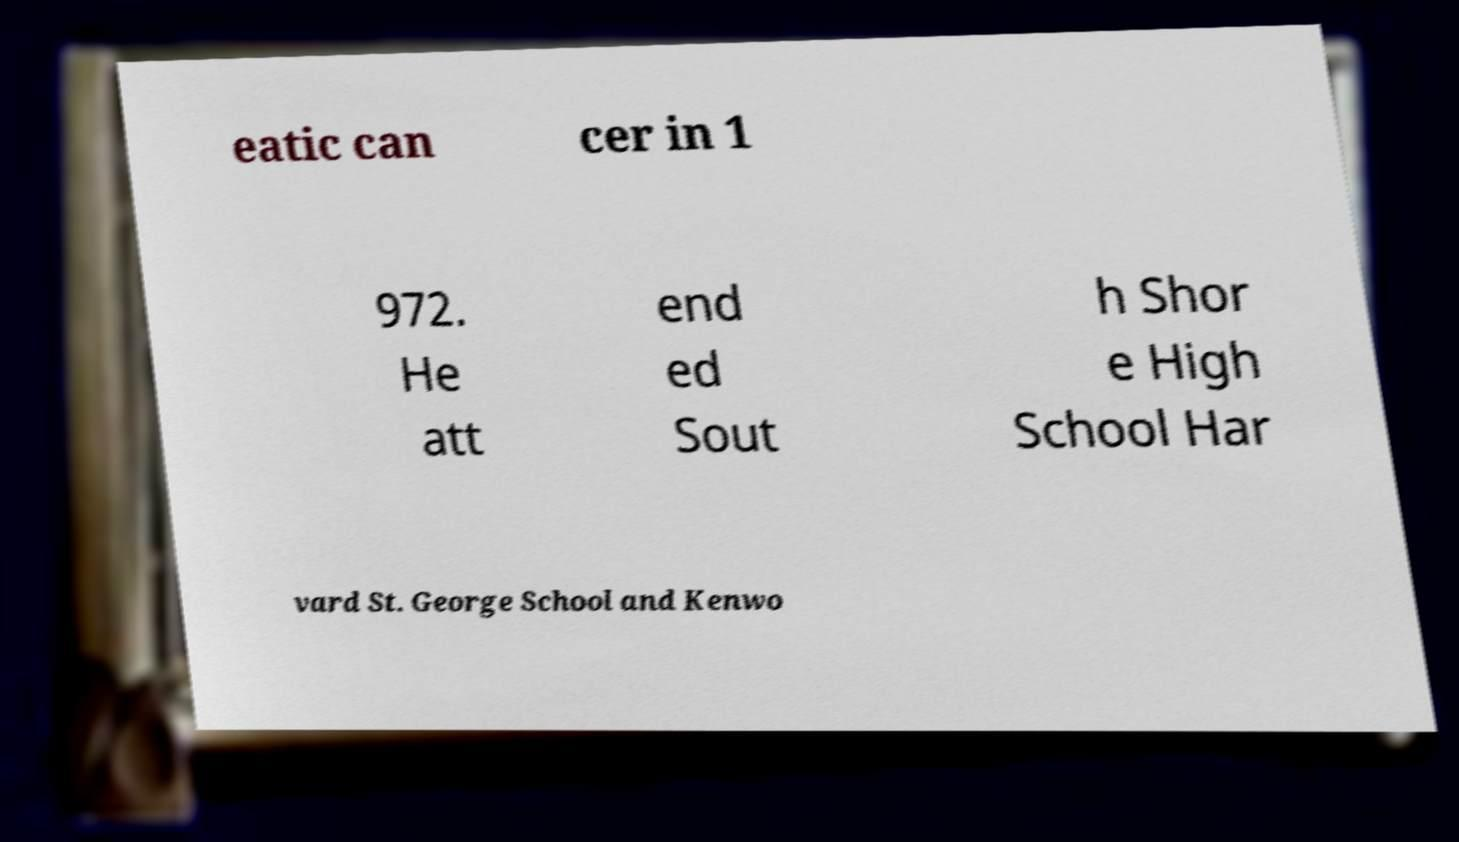Please read and relay the text visible in this image. What does it say? eatic can cer in 1 972. He att end ed Sout h Shor e High School Har vard St. George School and Kenwo 